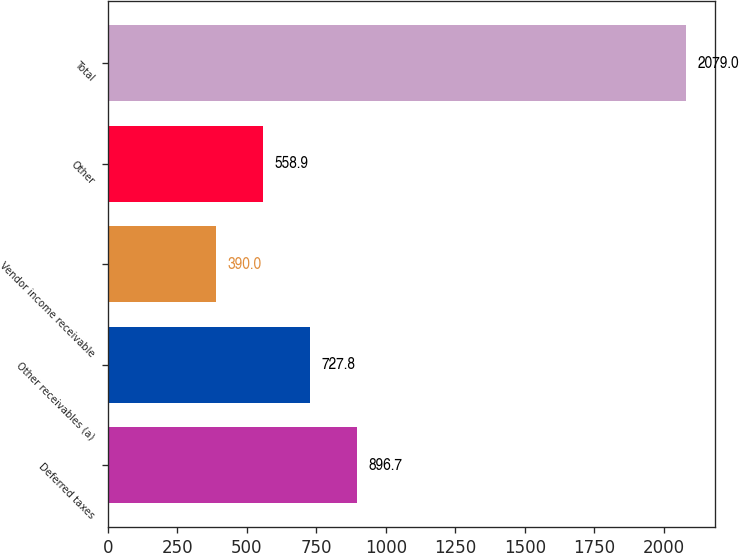<chart> <loc_0><loc_0><loc_500><loc_500><bar_chart><fcel>Deferred taxes<fcel>Other receivables (a)<fcel>Vendor income receivable<fcel>Other<fcel>Total<nl><fcel>896.7<fcel>727.8<fcel>390<fcel>558.9<fcel>2079<nl></chart> 